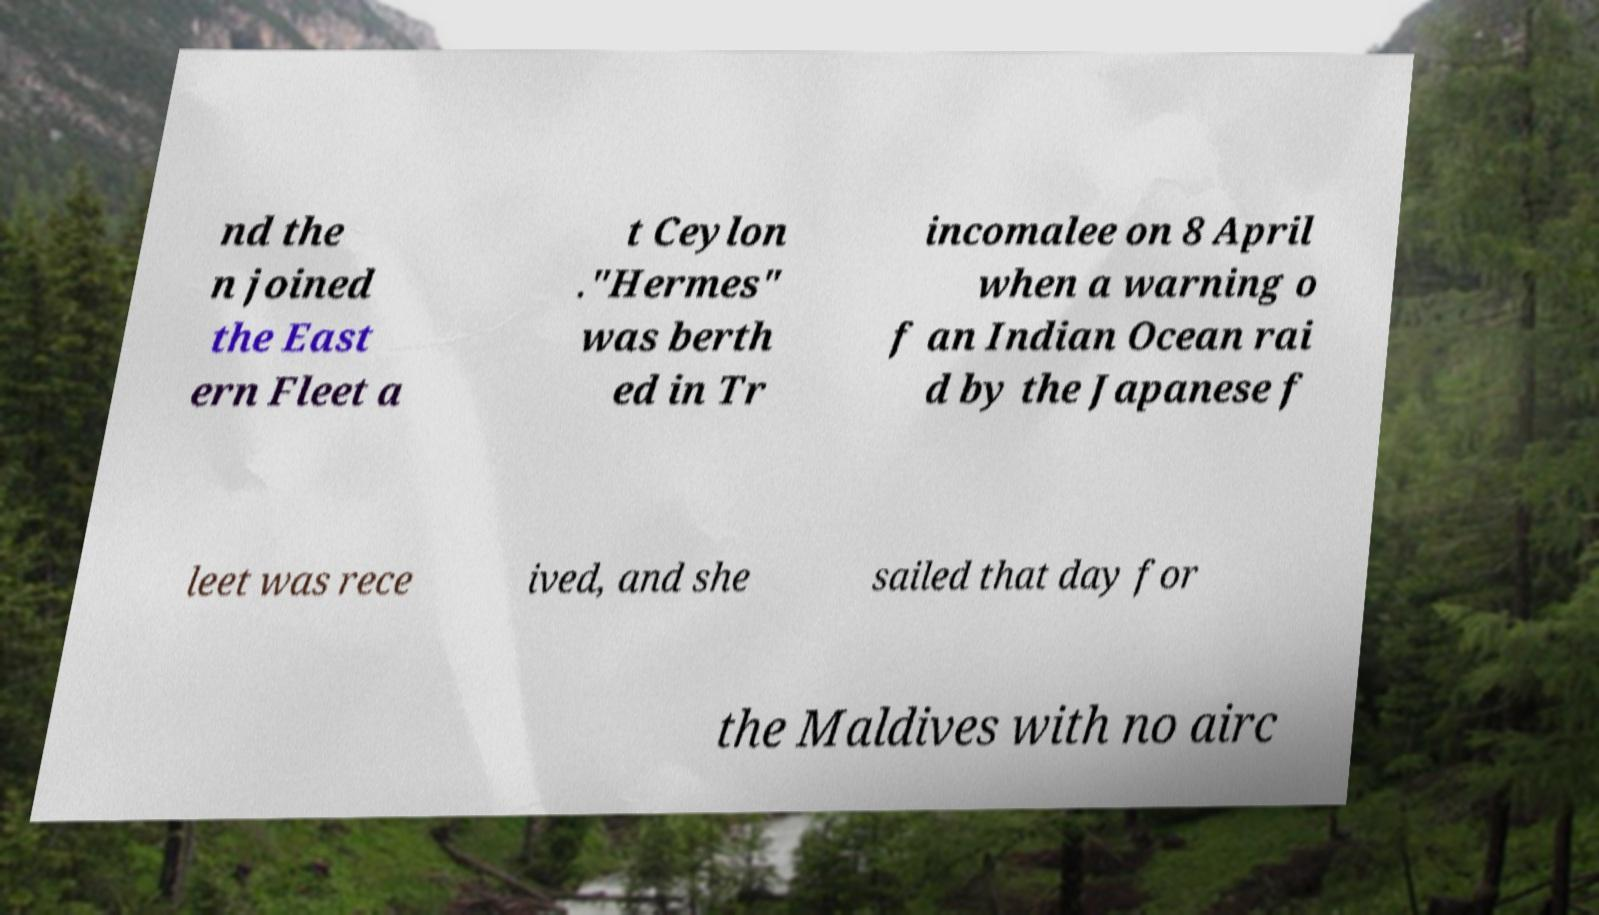I need the written content from this picture converted into text. Can you do that? nd the n joined the East ern Fleet a t Ceylon ."Hermes" was berth ed in Tr incomalee on 8 April when a warning o f an Indian Ocean rai d by the Japanese f leet was rece ived, and she sailed that day for the Maldives with no airc 